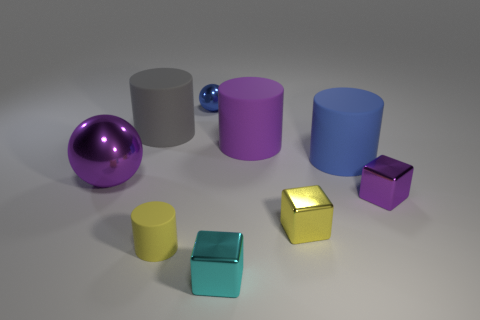What number of big things are metal things or blue matte things?
Ensure brevity in your answer.  2. How many cubes are both in front of the small rubber cylinder and to the right of the purple rubber thing?
Offer a terse response. 0. Is the material of the tiny ball the same as the purple thing in front of the large shiny thing?
Offer a terse response. Yes. How many purple objects are either objects or tiny metal balls?
Keep it short and to the point. 3. Are there any red blocks that have the same size as the yellow metallic thing?
Offer a terse response. No. There is a purple thing in front of the metal object to the left of the cylinder that is in front of the purple shiny cube; what is it made of?
Ensure brevity in your answer.  Metal. Is the number of rubber objects that are in front of the big purple shiny ball the same as the number of blue cylinders?
Your response must be concise. Yes. Is the material of the small object behind the large gray matte cylinder the same as the yellow object that is on the right side of the blue metal sphere?
Your response must be concise. Yes. What number of objects are either big gray matte things or things behind the large sphere?
Offer a terse response. 4. Are there any big cyan metallic objects that have the same shape as the small cyan object?
Provide a short and direct response. No. 